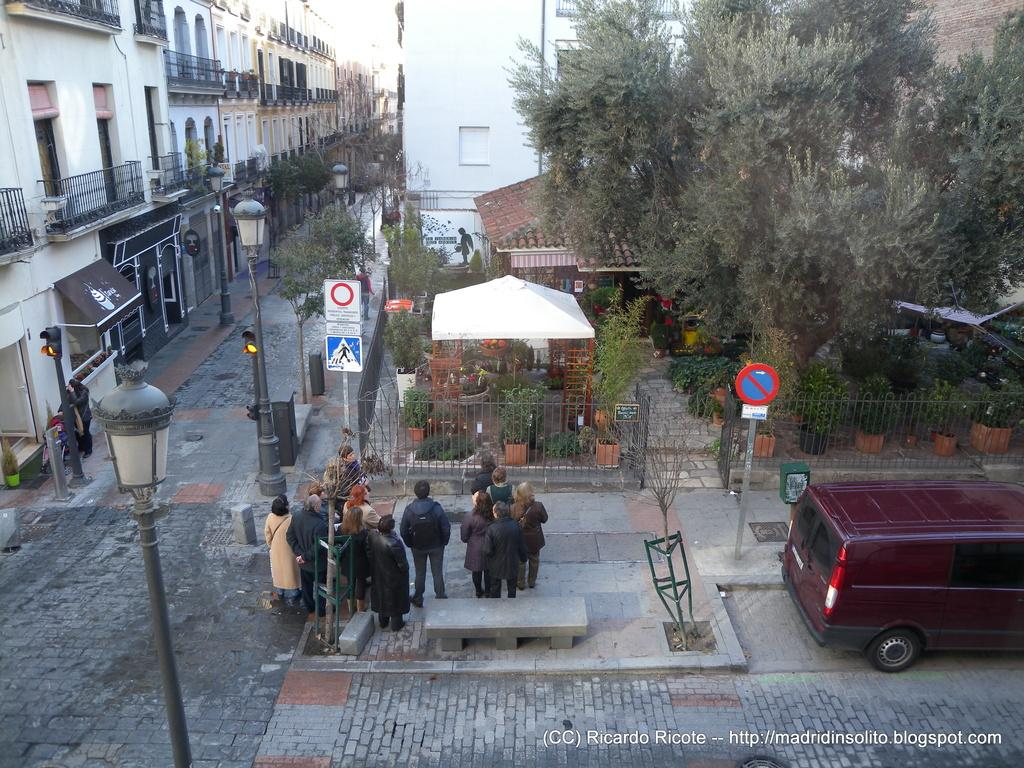How many people are in the group visible in the image? There is a group of people standing in the image, but the exact number cannot be determined from the provided facts. What type of vehicle is in the image? There is a vehicle in the image, but the specific type cannot be determined from the provided facts. What are the poles used for in the image? The purpose of the poles in the image cannot be determined from the provided facts. What do the signboards indicate in the image? The information on the signboards in the image cannot be determined from the provided facts. What is the purpose of the tent in the image? The purpose of the tent in the image cannot be determined from the provided facts. What is the function of the sun shade in the image? The function of the sun shade in the image cannot be determined from the provided facts. What type of house plants are present in the image? The type of house plants in the image cannot be determined from the provided facts. What is the purpose of the fence in the image? The purpose of the fence in the image cannot be determined from the provided facts. What type of lights are visible in the image? The type of lights in the image cannot be determined from the provided facts. What type of trees are visible in the image? The type of trees in the image cannot be determined from the provided facts. What can be seen in the background of the image? There are buildings in the background of the image, but the specific type or purpose cannot be determined from the provided facts. How many pears are on the representative scale in the image? There is no representative scale or pears present in the image. 